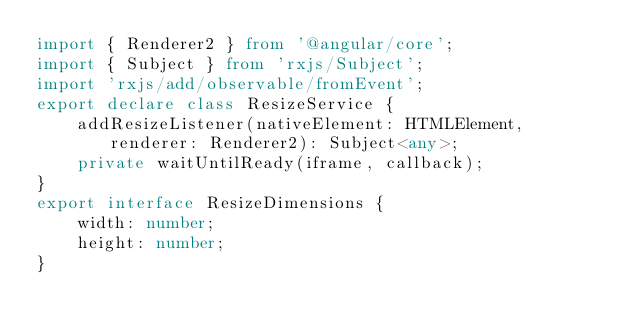<code> <loc_0><loc_0><loc_500><loc_500><_TypeScript_>import { Renderer2 } from '@angular/core';
import { Subject } from 'rxjs/Subject';
import 'rxjs/add/observable/fromEvent';
export declare class ResizeService {
    addResizeListener(nativeElement: HTMLElement, renderer: Renderer2): Subject<any>;
    private waitUntilReady(iframe, callback);
}
export interface ResizeDimensions {
    width: number;
    height: number;
}
</code> 